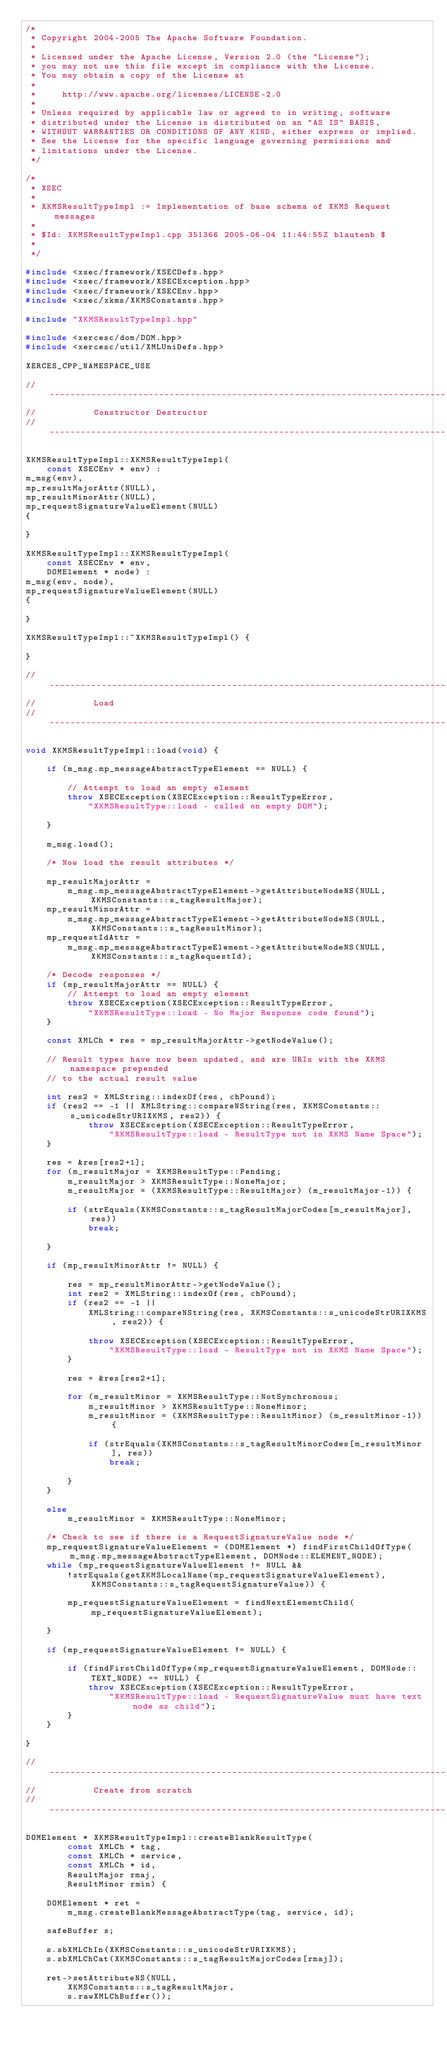<code> <loc_0><loc_0><loc_500><loc_500><_C++_>/*
 * Copyright 2004-2005 The Apache Software Foundation.
 *
 * Licensed under the Apache License, Version 2.0 (the "License");
 * you may not use this file except in compliance with the License.
 * You may obtain a copy of the License at
 *
 *     http://www.apache.org/licenses/LICENSE-2.0
 *
 * Unless required by applicable law or agreed to in writing, software
 * distributed under the License is distributed on an "AS IS" BASIS,
 * WITHOUT WARRANTIES OR CONDITIONS OF ANY KIND, either express or implied.
 * See the License for the specific language governing permissions and
 * limitations under the License.
 */

/*
 * XSEC
 *
 * XKMSResultTypeImpl := Implementation of base schema of XKMS Request messages
 *
 * $Id: XKMSResultTypeImpl.cpp 351366 2005-06-04 11:44:55Z blautenb $
 *
 */

#include <xsec/framework/XSECDefs.hpp>
#include <xsec/framework/XSECException.hpp>
#include <xsec/framework/XSECEnv.hpp>
#include <xsec/xkms/XKMSConstants.hpp>

#include "XKMSResultTypeImpl.hpp"

#include <xercesc/dom/DOM.hpp>
#include <xercesc/util/XMLUniDefs.hpp>

XERCES_CPP_NAMESPACE_USE

// --------------------------------------------------------------------------------
//           Constructor Destructor
// --------------------------------------------------------------------------------

XKMSResultTypeImpl::XKMSResultTypeImpl(
	const XSECEnv * env) :
m_msg(env),
mp_resultMajorAttr(NULL),
mp_resultMinorAttr(NULL),
mp_requestSignatureValueElement(NULL)
{

}

XKMSResultTypeImpl::XKMSResultTypeImpl(
	const XSECEnv * env, 
	DOMElement * node) :
m_msg(env, node),
mp_requestSignatureValueElement(NULL)
{

}

XKMSResultTypeImpl::~XKMSResultTypeImpl() {

}
	
// --------------------------------------------------------------------------------
//           Load
// --------------------------------------------------------------------------------

void XKMSResultTypeImpl::load(void) {

	if (m_msg.mp_messageAbstractTypeElement == NULL) {

		// Attempt to load an empty element
		throw XSECException(XSECException::ResultTypeError,
			"XKMSResultType::load - called on empty DOM");

	}

	m_msg.load();

	/* Now load the result attributes */

	mp_resultMajorAttr = 
		m_msg.mp_messageAbstractTypeElement->getAttributeNodeNS(NULL, XKMSConstants::s_tagResultMajor);
	mp_resultMinorAttr = 
		m_msg.mp_messageAbstractTypeElement->getAttributeNodeNS(NULL, XKMSConstants::s_tagResultMinor);
	mp_requestIdAttr =
		m_msg.mp_messageAbstractTypeElement->getAttributeNodeNS(NULL, XKMSConstants::s_tagRequestId);

	/* Decode responses */
	if (mp_resultMajorAttr == NULL) {
		// Attempt to load an empty element
		throw XSECException(XSECException::ResultTypeError,
			"XKMSResultType::load - No Major Response code found");
	}

	const XMLCh * res = mp_resultMajorAttr->getNodeValue();

	// Result types have now been updated, and are URIs with the XKMS namespace prepended
	// to the actual result value

	int res2 = XMLString::indexOf(res, chPound);
	if (res2 == -1 || XMLString::compareNString(res, XKMSConstants::s_unicodeStrURIXKMS, res2)) {
			throw XSECException(XSECException::ResultTypeError,
				"XKMSResultType::load - ResultType not in XKMS Name Space");
	}

	res = &res[res2+1];
	for (m_resultMajor = XKMSResultType::Pending; 
		m_resultMajor > XKMSResultType::NoneMajor; 
		m_resultMajor = (XKMSResultType::ResultMajor) (m_resultMajor-1)) {

		if (strEquals(XKMSConstants::s_tagResultMajorCodes[m_resultMajor], res))
			break;

	}

	if (mp_resultMinorAttr != NULL) {

		res = mp_resultMinorAttr->getNodeValue();
		int res2 = XMLString::indexOf(res, chPound);
		if (res2 == -1 ||
			XMLString::compareNString(res, XKMSConstants::s_unicodeStrURIXKMS, res2)) {

			throw XSECException(XSECException::ResultTypeError,
				"XKMSResultType::load - ResultType not in XKMS Name Space");
		}

		res = &res[res2+1];

		for (m_resultMinor = XKMSResultType::NotSynchronous; 
			m_resultMinor > XKMSResultType::NoneMinor; 
			m_resultMinor = (XKMSResultType::ResultMinor) (m_resultMinor-1)) {

			if (strEquals(XKMSConstants::s_tagResultMinorCodes[m_resultMinor], res))
				break;

		}
	}

	else
		m_resultMinor = XKMSResultType::NoneMinor;

	/* Check to see if there is a RequestSignatureValue node */
	mp_requestSignatureValueElement = (DOMElement *) findFirstChildOfType(m_msg.mp_messageAbstractTypeElement, DOMNode::ELEMENT_NODE);
	while (mp_requestSignatureValueElement != NULL && 
		!strEquals(getXKMSLocalName(mp_requestSignatureValueElement), XKMSConstants::s_tagRequestSignatureValue)) {

		mp_requestSignatureValueElement = findNextElementChild(mp_requestSignatureValueElement);

	}

	if (mp_requestSignatureValueElement != NULL) {

		if (findFirstChildOfType(mp_requestSignatureValueElement, DOMNode::TEXT_NODE) == NULL) {
			throw XSECException(XSECException::ResultTypeError,
				"XKMSResultType::load - RequestSignatureValue must have text node as child");
		}
	}

}

// --------------------------------------------------------------------------------
//           Create from scratch
// --------------------------------------------------------------------------------

DOMElement * XKMSResultTypeImpl::createBlankResultType(
		const XMLCh * tag,
		const XMLCh * service,
		const XMLCh * id,
		ResultMajor rmaj,
		ResultMinor rmin) {

	DOMElement * ret = 
		m_msg.createBlankMessageAbstractType(tag, service, id);

	safeBuffer s;

	s.sbXMLChIn(XKMSConstants::s_unicodeStrURIXKMS);
	s.sbXMLChCat(XKMSConstants::s_tagResultMajorCodes[rmaj]);

	ret->setAttributeNS(NULL, 
		XKMSConstants::s_tagResultMajor,
		s.rawXMLChBuffer());
</code> 